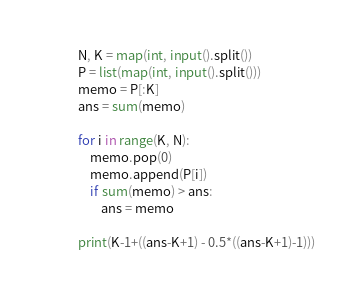Convert code to text. <code><loc_0><loc_0><loc_500><loc_500><_Python_>N, K = map(int, input().split())
P = list(map(int, input().split()))
memo = P[:K]
ans = sum(memo)

for i in range(K, N):
    memo.pop(0)
    memo.append(P[i])
    if sum(memo) > ans:
        ans = memo

print(K-1+((ans-K+1) - 0.5*((ans-K+1)-1)))</code> 